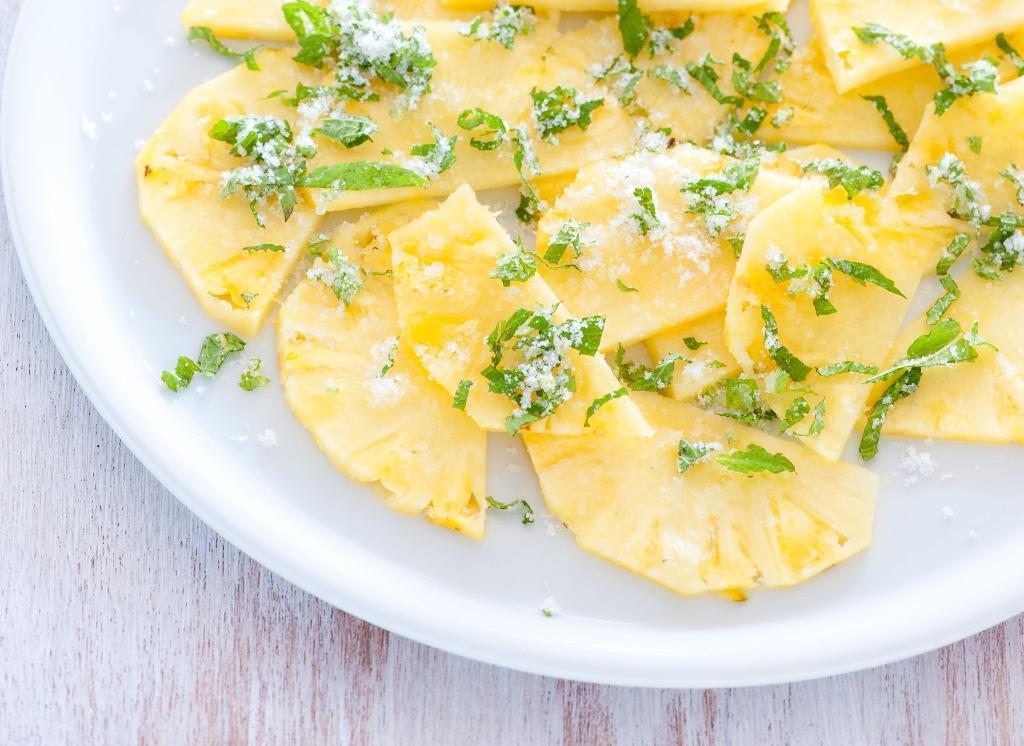Describe this image in one or two sentences. In this image we can see a plate with some food item on the table. 